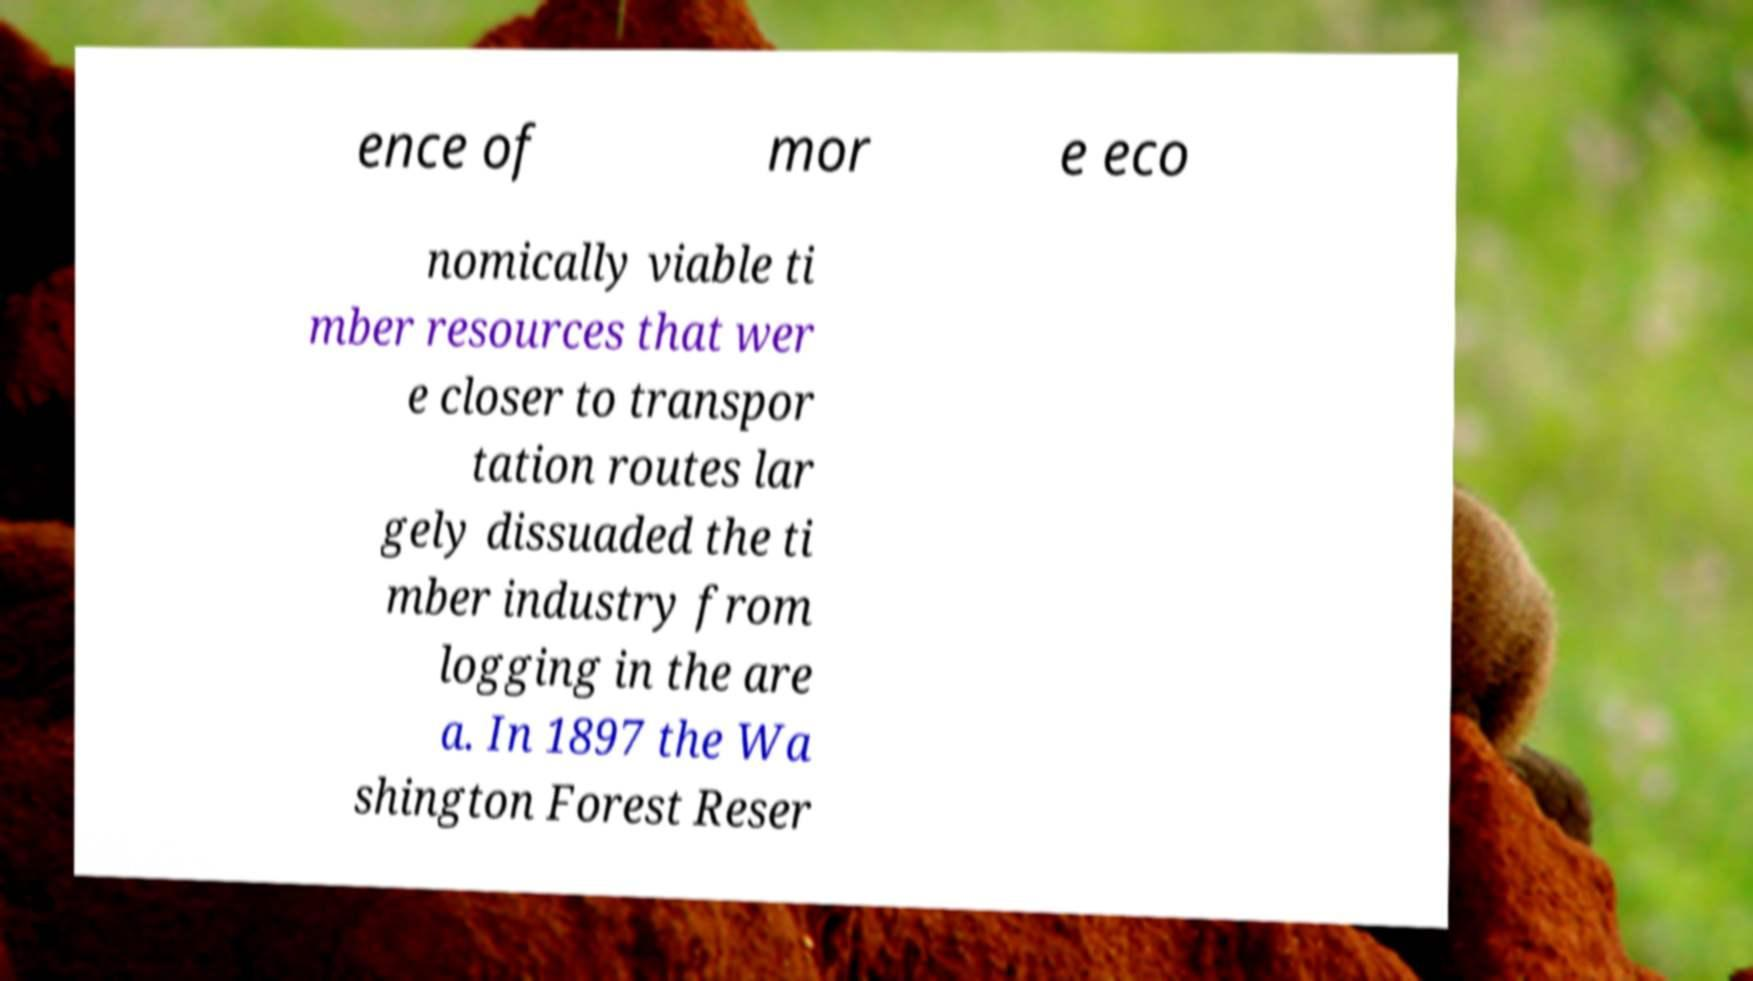What messages or text are displayed in this image? I need them in a readable, typed format. ence of mor e eco nomically viable ti mber resources that wer e closer to transpor tation routes lar gely dissuaded the ti mber industry from logging in the are a. In 1897 the Wa shington Forest Reser 